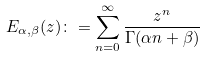<formula> <loc_0><loc_0><loc_500><loc_500>E _ { \alpha , \beta } ( z ) \colon = \sum ^ { \infty } _ { n = 0 } \frac { z ^ { n } } { \Gamma ( \alpha n + \beta ) }</formula> 